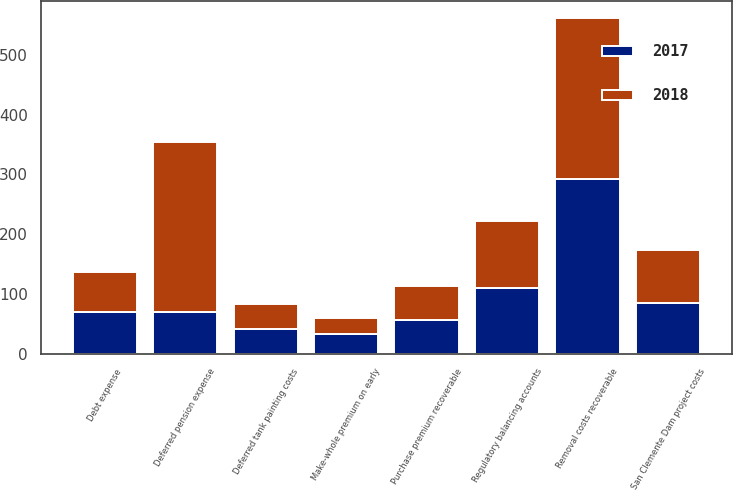Convert chart to OTSL. <chart><loc_0><loc_0><loc_500><loc_500><stacked_bar_chart><ecel><fcel>Deferred pension expense<fcel>Removal costs recoverable<fcel>Regulatory balancing accounts<fcel>San Clemente Dam project costs<fcel>Debt expense<fcel>Purchase premium recoverable<fcel>Deferred tank painting costs<fcel>Make-whole premium on early<nl><fcel>2017<fcel>70<fcel>292<fcel>110<fcel>85<fcel>70<fcel>56<fcel>42<fcel>33<nl><fcel>2018<fcel>285<fcel>269<fcel>113<fcel>89<fcel>67<fcel>57<fcel>42<fcel>27<nl></chart> 